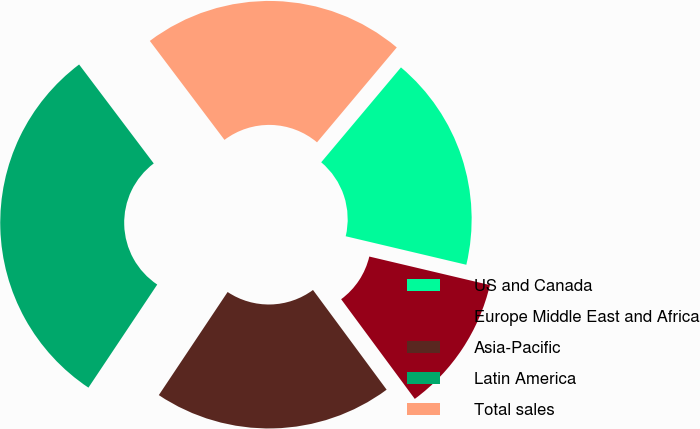Convert chart to OTSL. <chart><loc_0><loc_0><loc_500><loc_500><pie_chart><fcel>US and Canada<fcel>Europe Middle East and Africa<fcel>Asia-Pacific<fcel>Latin America<fcel>Total sales<nl><fcel>17.57%<fcel>11.18%<fcel>19.49%<fcel>30.35%<fcel>21.41%<nl></chart> 